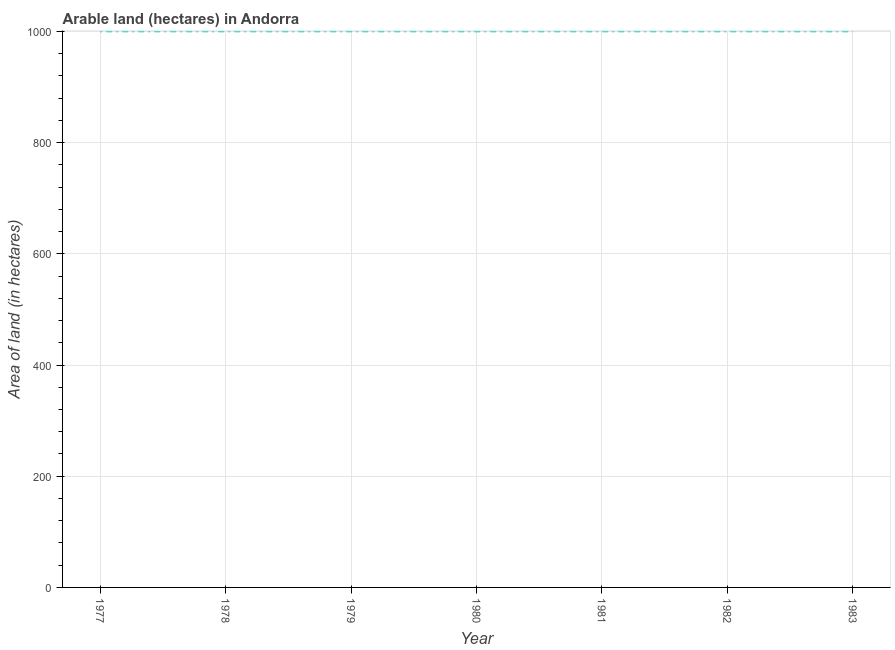What is the area of land in 1979?
Offer a very short reply. 1000. Across all years, what is the maximum area of land?
Ensure brevity in your answer.  1000. Across all years, what is the minimum area of land?
Ensure brevity in your answer.  1000. In which year was the area of land maximum?
Ensure brevity in your answer.  1977. In which year was the area of land minimum?
Give a very brief answer. 1977. What is the sum of the area of land?
Make the answer very short. 7000. What is the average area of land per year?
Ensure brevity in your answer.  1000. What is the ratio of the area of land in 1980 to that in 1981?
Offer a very short reply. 1. What is the difference between the highest and the lowest area of land?
Offer a terse response. 0. In how many years, is the area of land greater than the average area of land taken over all years?
Offer a very short reply. 0. Does the area of land monotonically increase over the years?
Offer a terse response. No. How many lines are there?
Provide a short and direct response. 1. Are the values on the major ticks of Y-axis written in scientific E-notation?
Give a very brief answer. No. Does the graph contain any zero values?
Your response must be concise. No. What is the title of the graph?
Make the answer very short. Arable land (hectares) in Andorra. What is the label or title of the X-axis?
Provide a succinct answer. Year. What is the label or title of the Y-axis?
Provide a succinct answer. Area of land (in hectares). What is the Area of land (in hectares) of 1977?
Make the answer very short. 1000. What is the Area of land (in hectares) in 1978?
Provide a succinct answer. 1000. What is the Area of land (in hectares) in 1979?
Keep it short and to the point. 1000. What is the Area of land (in hectares) of 1981?
Your answer should be compact. 1000. What is the Area of land (in hectares) in 1982?
Your answer should be very brief. 1000. What is the Area of land (in hectares) of 1983?
Your answer should be compact. 1000. What is the difference between the Area of land (in hectares) in 1977 and 1981?
Ensure brevity in your answer.  0. What is the difference between the Area of land (in hectares) in 1978 and 1979?
Give a very brief answer. 0. What is the difference between the Area of land (in hectares) in 1978 and 1980?
Keep it short and to the point. 0. What is the difference between the Area of land (in hectares) in 1978 and 1981?
Ensure brevity in your answer.  0. What is the difference between the Area of land (in hectares) in 1978 and 1983?
Your answer should be compact. 0. What is the difference between the Area of land (in hectares) in 1980 and 1982?
Ensure brevity in your answer.  0. What is the difference between the Area of land (in hectares) in 1980 and 1983?
Offer a very short reply. 0. What is the difference between the Area of land (in hectares) in 1981 and 1982?
Make the answer very short. 0. What is the ratio of the Area of land (in hectares) in 1977 to that in 1978?
Your answer should be very brief. 1. What is the ratio of the Area of land (in hectares) in 1977 to that in 1979?
Offer a terse response. 1. What is the ratio of the Area of land (in hectares) in 1977 to that in 1983?
Keep it short and to the point. 1. What is the ratio of the Area of land (in hectares) in 1978 to that in 1979?
Give a very brief answer. 1. What is the ratio of the Area of land (in hectares) in 1978 to that in 1980?
Your answer should be very brief. 1. What is the ratio of the Area of land (in hectares) in 1979 to that in 1982?
Give a very brief answer. 1. What is the ratio of the Area of land (in hectares) in 1980 to that in 1981?
Offer a very short reply. 1. What is the ratio of the Area of land (in hectares) in 1980 to that in 1983?
Provide a short and direct response. 1. What is the ratio of the Area of land (in hectares) in 1981 to that in 1982?
Offer a very short reply. 1. 